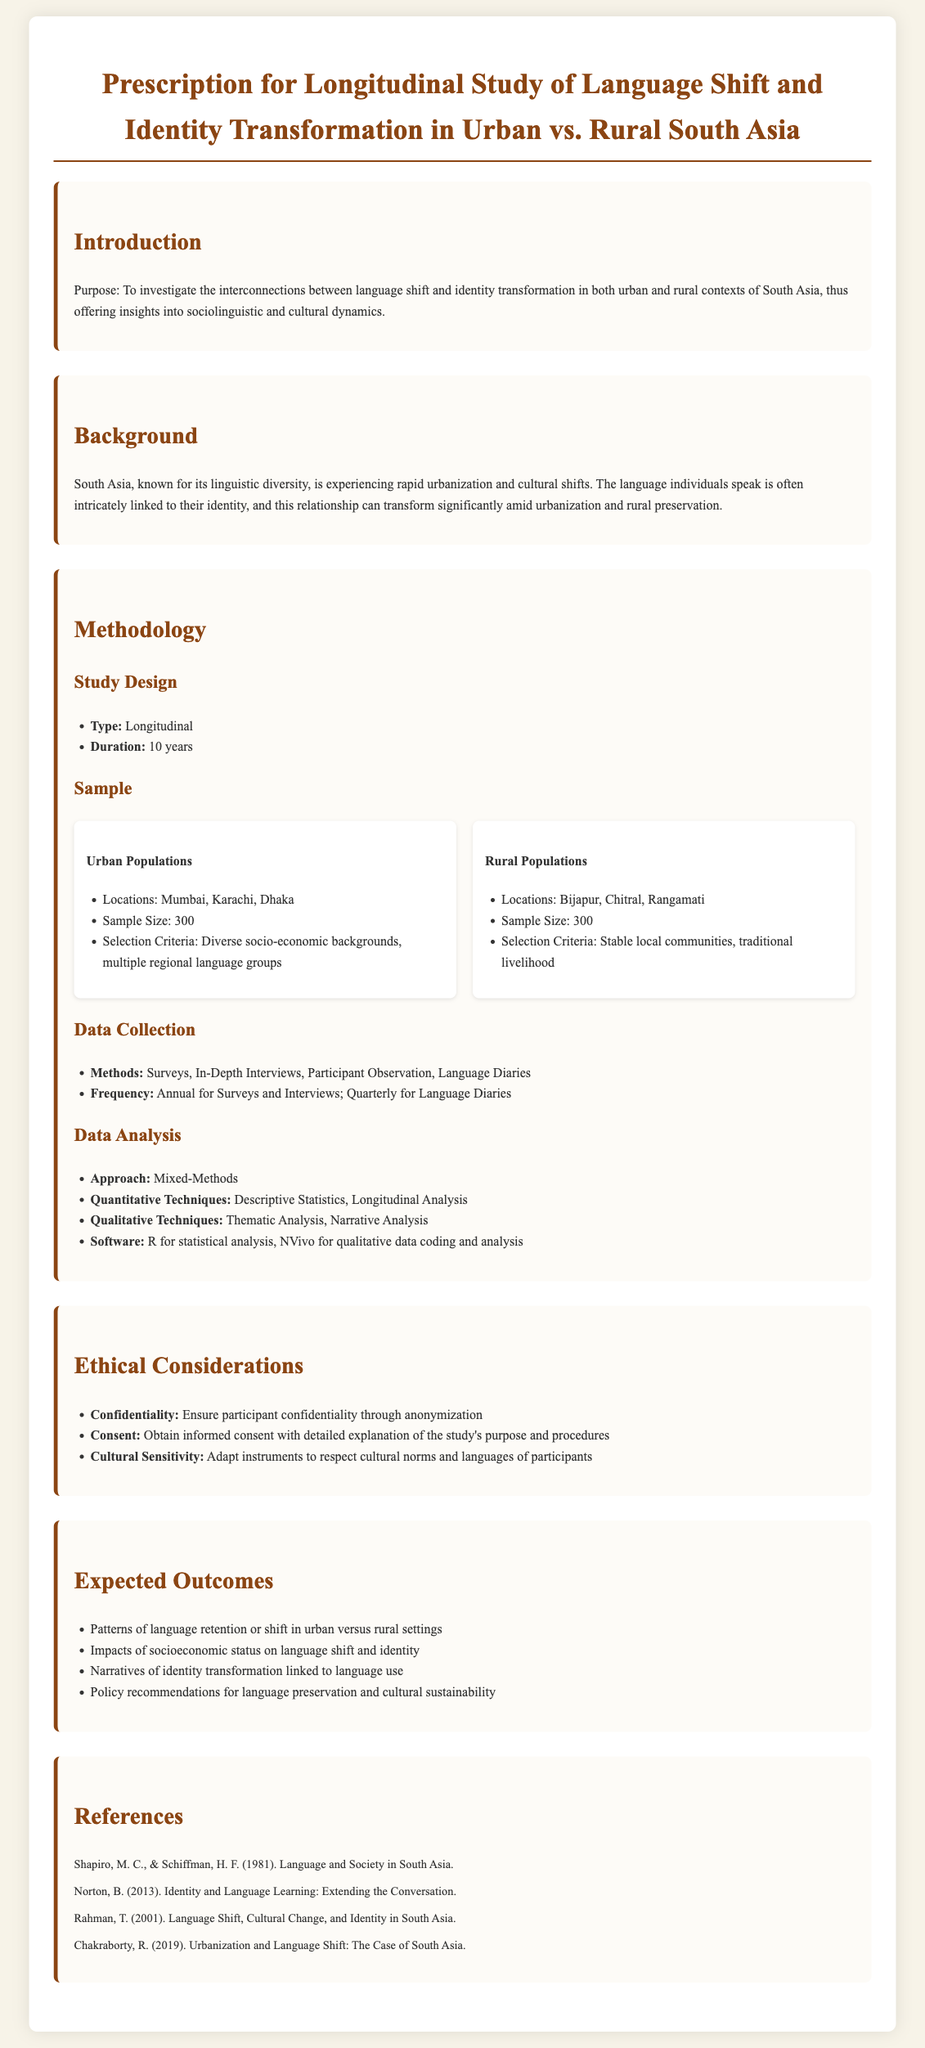What is the purpose of the study? The purpose of the study is to investigate the interconnections between language shift and identity transformation in both urban and rural contexts of South Asia.
Answer: To investigate the interconnections between language shift and identity transformation What is the sample size for urban populations? The sample size for urban populations is explicitly stated in the methodology section of the document.
Answer: 300 How long is the study's duration? The duration of the study is specified in the study design section.
Answer: 10 years What data collection methods are mentioned? The document lists the methods used for data collection.
Answer: Surveys, In-Depth Interviews, Participant Observation, Language Diaries What locations are included for rural populations? The document outlines specific locations for rural populations under the sample section.
Answer: Bijapur, Chitral, Rangamati What ethical consideration focuses on participant rights? The ethical considerations section highlights key ethical principles.
Answer: Consent Which software is used for qualitative data coding? The data analysis section specifies the software utilized for qualitative analysis.
Answer: NVivo What impact is expected on language shift according to socioeconomic status? The expected outcomes section suggests a specific correlation concerning the socioeconomic factor.
Answer: Impacts of socioeconomic status on language shift and identity Which two cities are mentioned under urban populations apart from Mumbai? The document lists additional cities involved in urban populations in the sample section.
Answer: Karachi, Dhaka 